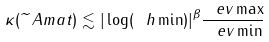Convert formula to latex. <formula><loc_0><loc_0><loc_500><loc_500>\kappa ( \widetilde { \ } A m a t ) \lesssim | \log ( \ h \min ) | ^ { \beta } \frac { \ e v \max } { \ e v \min }</formula> 